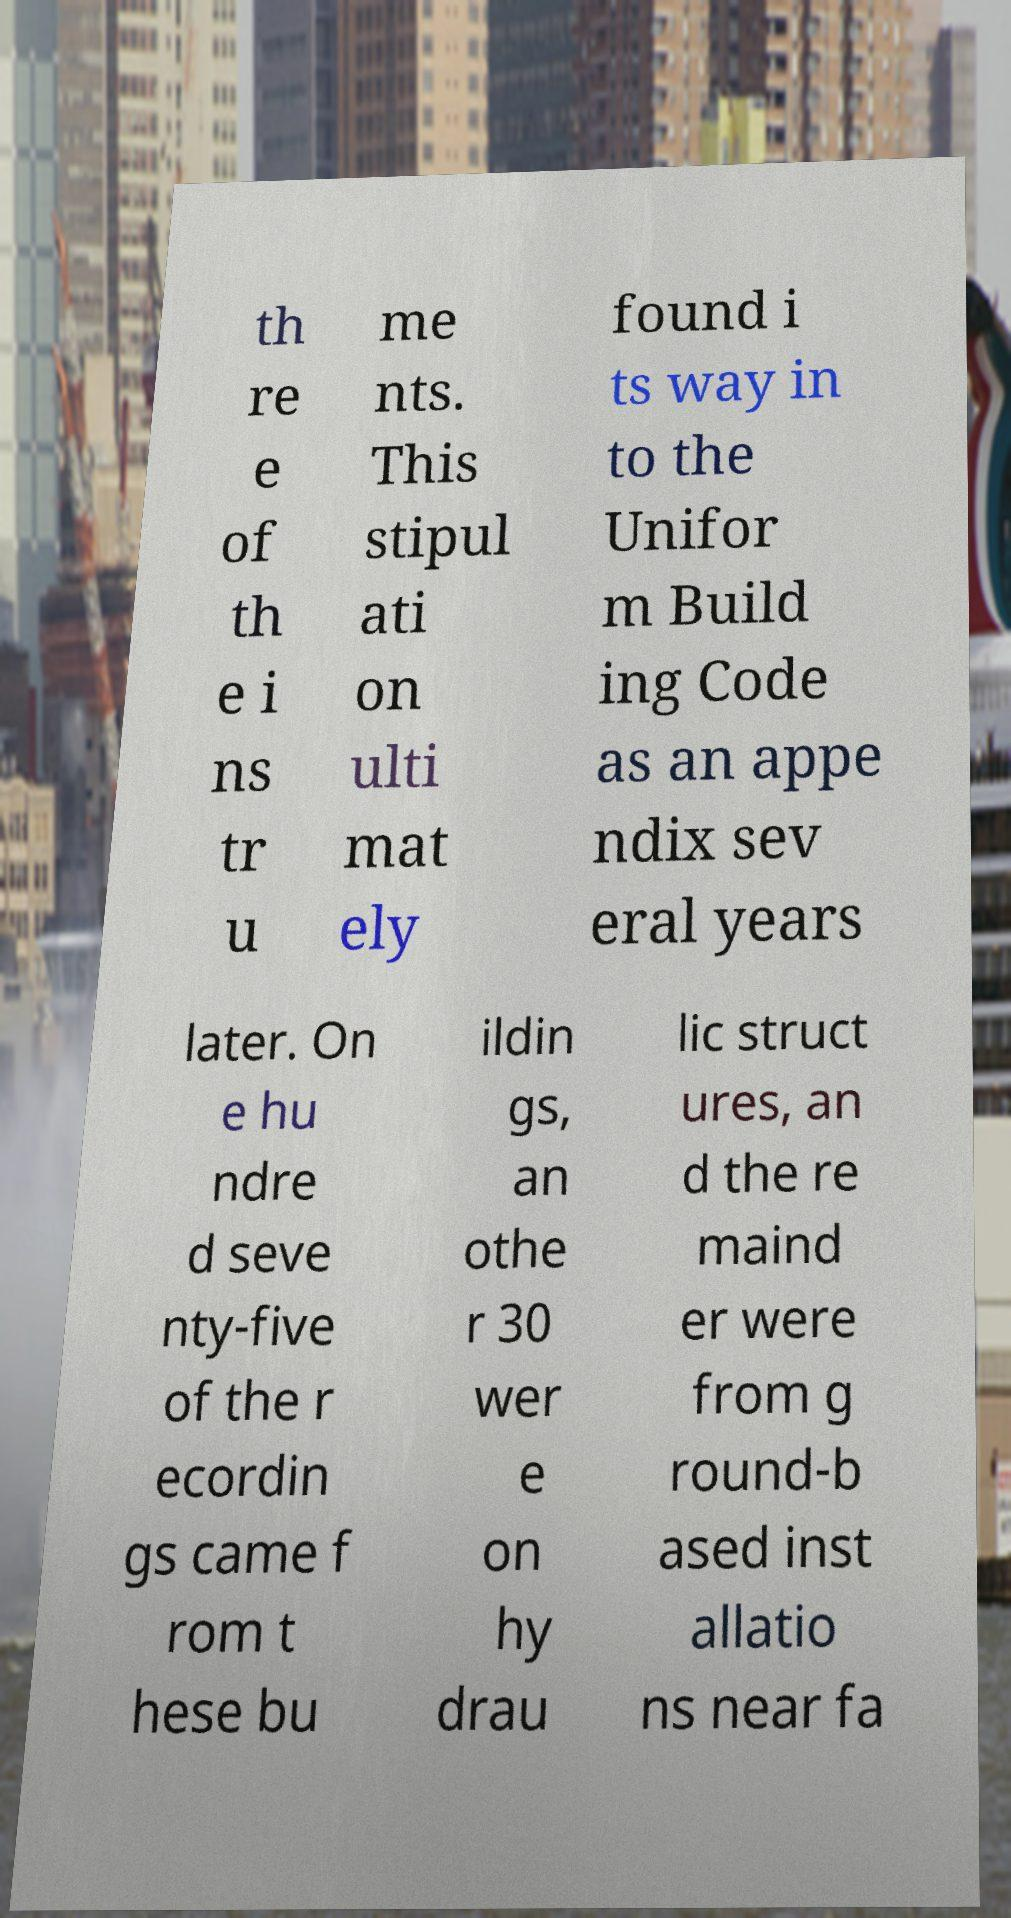Can you read and provide the text displayed in the image?This photo seems to have some interesting text. Can you extract and type it out for me? th re e of th e i ns tr u me nts. This stipul ati on ulti mat ely found i ts way in to the Unifor m Build ing Code as an appe ndix sev eral years later. On e hu ndre d seve nty-five of the r ecordin gs came f rom t hese bu ildin gs, an othe r 30 wer e on hy drau lic struct ures, an d the re maind er were from g round-b ased inst allatio ns near fa 